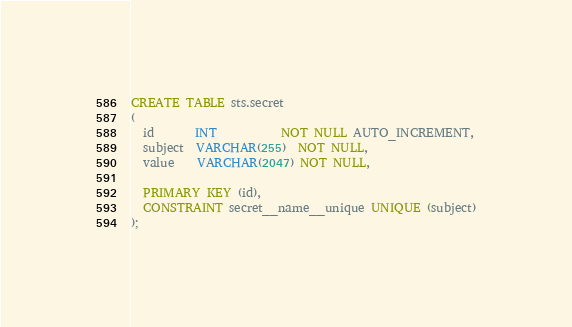<code> <loc_0><loc_0><loc_500><loc_500><_SQL_>CREATE TABLE sts.secret
(
  id       INT           NOT NULL AUTO_INCREMENT,
  subject  VARCHAR(255)  NOT NULL,
  value    VARCHAR(2047) NOT NULL,

  PRIMARY KEY (id),
  CONSTRAINT secret__name__unique UNIQUE (subject)
);
</code> 